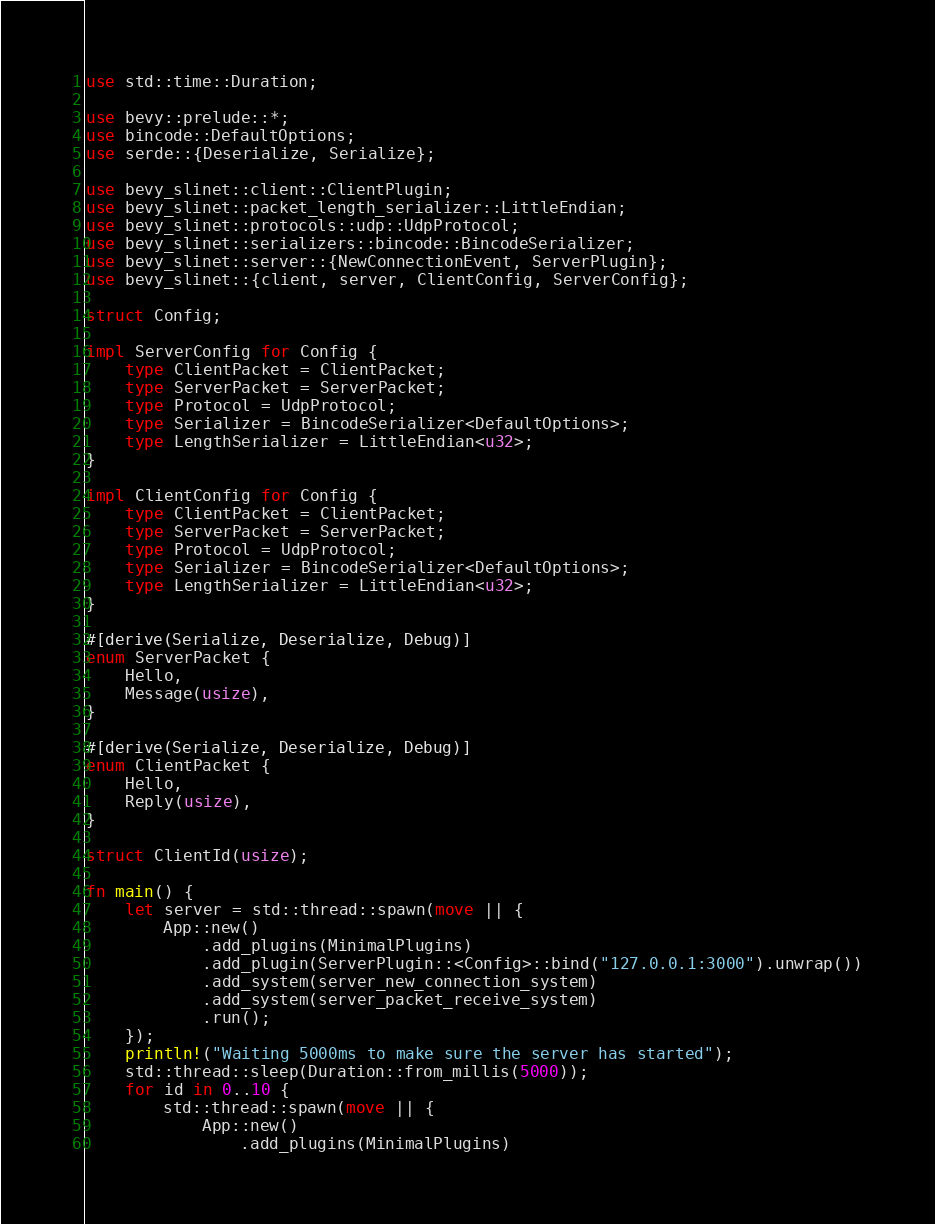Convert code to text. <code><loc_0><loc_0><loc_500><loc_500><_Rust_>use std::time::Duration;

use bevy::prelude::*;
use bincode::DefaultOptions;
use serde::{Deserialize, Serialize};

use bevy_slinet::client::ClientPlugin;
use bevy_slinet::packet_length_serializer::LittleEndian;
use bevy_slinet::protocols::udp::UdpProtocol;
use bevy_slinet::serializers::bincode::BincodeSerializer;
use bevy_slinet::server::{NewConnectionEvent, ServerPlugin};
use bevy_slinet::{client, server, ClientConfig, ServerConfig};

struct Config;

impl ServerConfig for Config {
    type ClientPacket = ClientPacket;
    type ServerPacket = ServerPacket;
    type Protocol = UdpProtocol;
    type Serializer = BincodeSerializer<DefaultOptions>;
    type LengthSerializer = LittleEndian<u32>;
}

impl ClientConfig for Config {
    type ClientPacket = ClientPacket;
    type ServerPacket = ServerPacket;
    type Protocol = UdpProtocol;
    type Serializer = BincodeSerializer<DefaultOptions>;
    type LengthSerializer = LittleEndian<u32>;
}

#[derive(Serialize, Deserialize, Debug)]
enum ServerPacket {
    Hello,
    Message(usize),
}

#[derive(Serialize, Deserialize, Debug)]
enum ClientPacket {
    Hello,
    Reply(usize),
}

struct ClientId(usize);

fn main() {
    let server = std::thread::spawn(move || {
        App::new()
            .add_plugins(MinimalPlugins)
            .add_plugin(ServerPlugin::<Config>::bind("127.0.0.1:3000").unwrap())
            .add_system(server_new_connection_system)
            .add_system(server_packet_receive_system)
            .run();
    });
    println!("Waiting 5000ms to make sure the server has started");
    std::thread::sleep(Duration::from_millis(5000));
    for id in 0..10 {
        std::thread::spawn(move || {
            App::new()
                .add_plugins(MinimalPlugins)</code> 